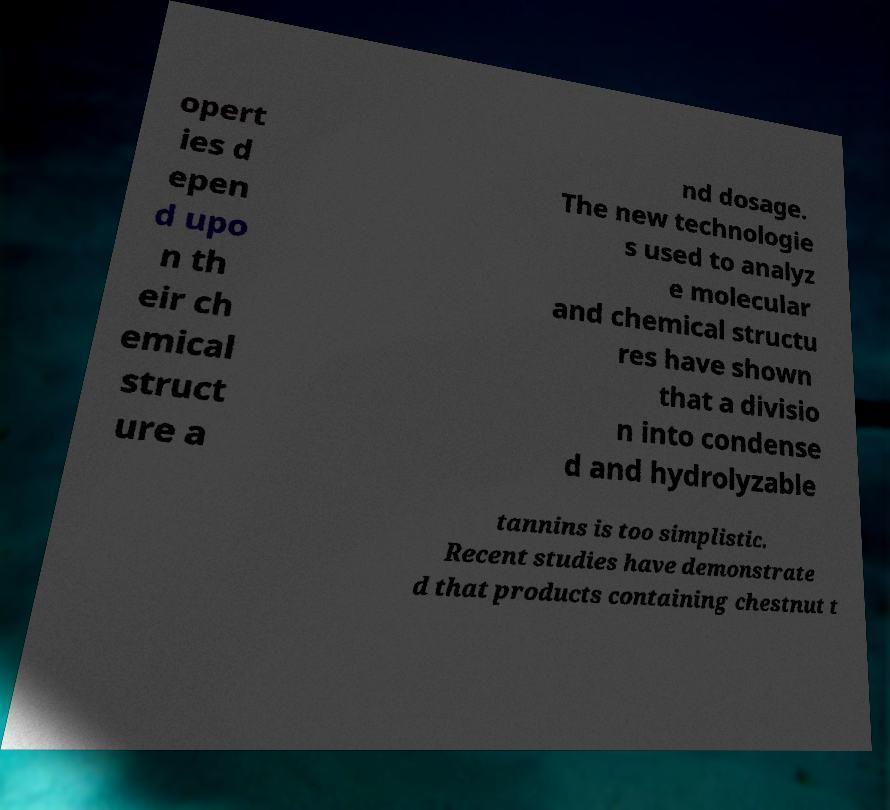Please identify and transcribe the text found in this image. opert ies d epen d upo n th eir ch emical struct ure a nd dosage. The new technologie s used to analyz e molecular and chemical structu res have shown that a divisio n into condense d and hydrolyzable tannins is too simplistic. Recent studies have demonstrate d that products containing chestnut t 